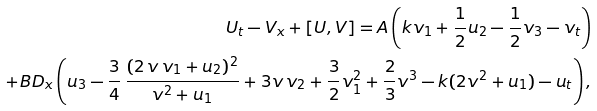<formula> <loc_0><loc_0><loc_500><loc_500>U _ { t } - V _ { x } + [ U , V ] = A \left ( k v _ { 1 } + \frac { 1 } { 2 } u _ { 2 } - \frac { 1 } { 2 } v _ { 3 } - v _ { t } \right ) \\ + B D _ { x } \left ( u _ { 3 } - \frac { 3 } { 4 } \, \frac { ( 2 \, v \, v _ { 1 } + u _ { 2 } ) ^ { 2 } } { v ^ { 2 } + u _ { 1 } } + 3 v \, v _ { 2 } + \frac { 3 } { 2 } v _ { 1 } ^ { 2 } + \frac { 2 } { 3 } v ^ { 3 } - k ( 2 v ^ { 2 } + u _ { 1 } ) - u _ { t } \right ) ,</formula> 